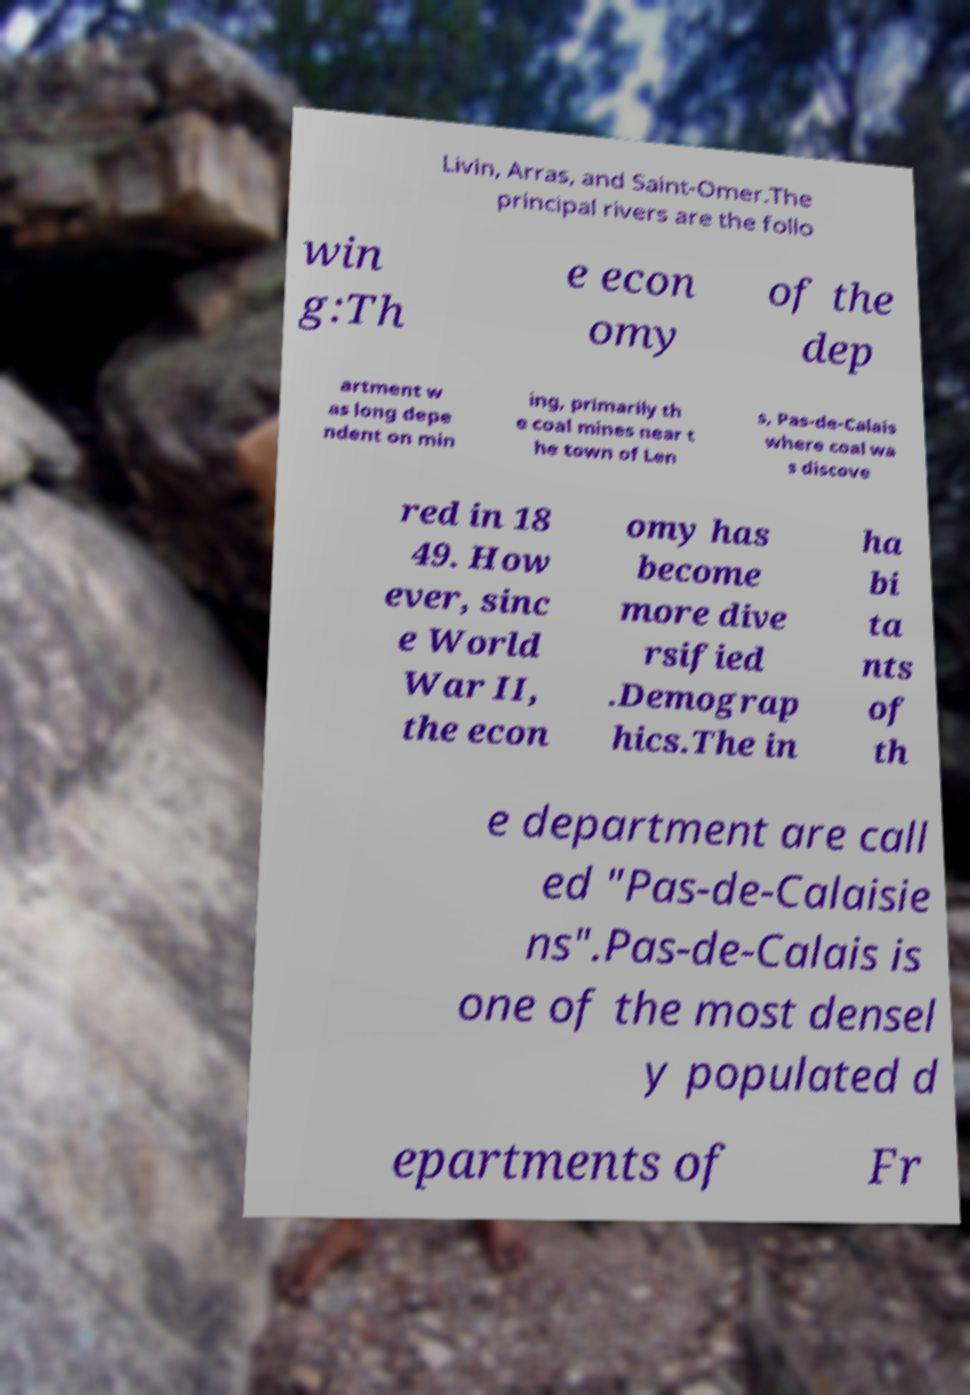There's text embedded in this image that I need extracted. Can you transcribe it verbatim? Livin, Arras, and Saint-Omer.The principal rivers are the follo win g:Th e econ omy of the dep artment w as long depe ndent on min ing, primarily th e coal mines near t he town of Len s, Pas-de-Calais where coal wa s discove red in 18 49. How ever, sinc e World War II, the econ omy has become more dive rsified .Demograp hics.The in ha bi ta nts of th e department are call ed "Pas-de-Calaisie ns".Pas-de-Calais is one of the most densel y populated d epartments of Fr 